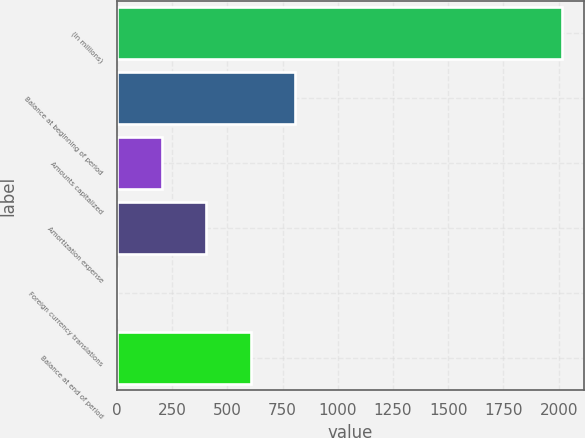<chart> <loc_0><loc_0><loc_500><loc_500><bar_chart><fcel>(In millions)<fcel>Balance at beginning of period<fcel>Amounts capitalized<fcel>Amortization expense<fcel>Foreign currency translations<fcel>Balance at end of period<nl><fcel>2014<fcel>806.2<fcel>202.3<fcel>403.6<fcel>1<fcel>604.9<nl></chart> 